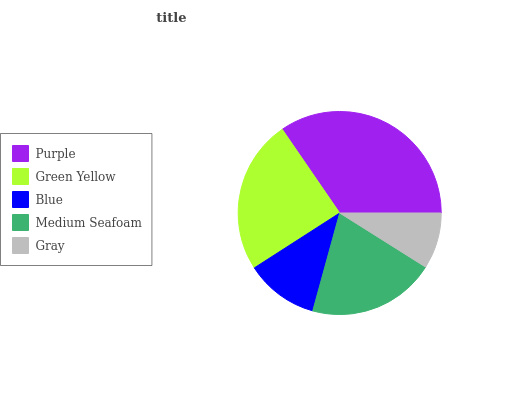Is Gray the minimum?
Answer yes or no. Yes. Is Purple the maximum?
Answer yes or no. Yes. Is Green Yellow the minimum?
Answer yes or no. No. Is Green Yellow the maximum?
Answer yes or no. No. Is Purple greater than Green Yellow?
Answer yes or no. Yes. Is Green Yellow less than Purple?
Answer yes or no. Yes. Is Green Yellow greater than Purple?
Answer yes or no. No. Is Purple less than Green Yellow?
Answer yes or no. No. Is Medium Seafoam the high median?
Answer yes or no. Yes. Is Medium Seafoam the low median?
Answer yes or no. Yes. Is Blue the high median?
Answer yes or no. No. Is Gray the low median?
Answer yes or no. No. 